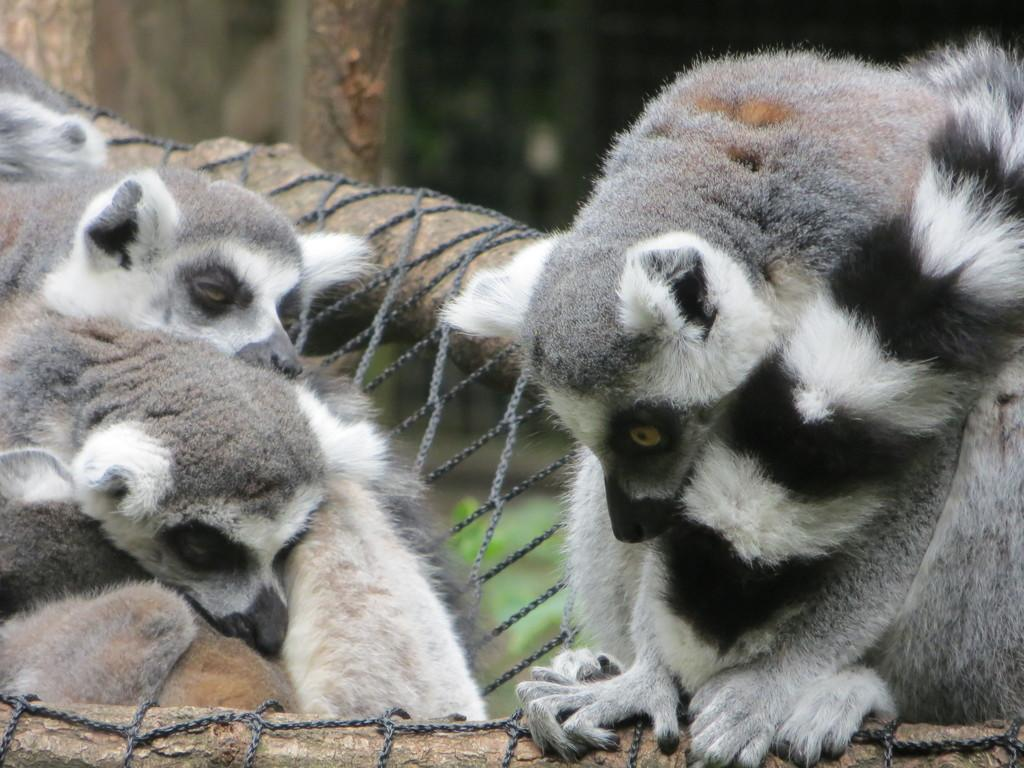What is located in the front of the image? There are animals in the front of the image. How would you describe the background of the image? The background of the image is blurry. What can be seen in the center of the image? There is a rope in the center of the image. What is the rope tied to? The rope is tied to a tree. What does the mom of the animals in the image look like? There is no mention of a mom in the image, so we cannot describe her appearance. 